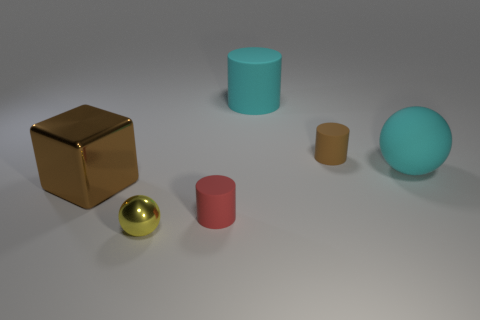What is the color of the other small object that is the same shape as the tiny red thing?
Your answer should be very brief. Brown. Is the number of cyan spheres left of the metallic cube greater than the number of brown metal cubes?
Your answer should be compact. No. What is the color of the small rubber cylinder that is right of the big matte cylinder?
Ensure brevity in your answer.  Brown. Is the size of the yellow object the same as the metal cube?
Make the answer very short. No. The cube has what size?
Your response must be concise. Large. What shape is the matte object that is the same color as the big cylinder?
Make the answer very short. Sphere. Is the number of metal things greater than the number of blue shiny cubes?
Provide a succinct answer. Yes. There is a tiny cylinder to the right of the cyan object that is to the left of the big thing that is to the right of the tiny brown rubber thing; what is its color?
Offer a terse response. Brown. There is a brown object that is on the right side of the tiny yellow ball; does it have the same shape as the small red matte object?
Offer a terse response. Yes. There is a matte thing that is the same size as the cyan cylinder; what color is it?
Provide a succinct answer. Cyan. 